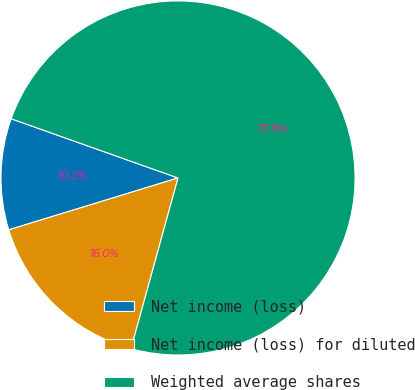<chart> <loc_0><loc_0><loc_500><loc_500><pie_chart><fcel>Net income (loss)<fcel>Net income (loss) for diluted<fcel>Weighted average shares<nl><fcel>10.16%<fcel>15.99%<fcel>73.85%<nl></chart> 